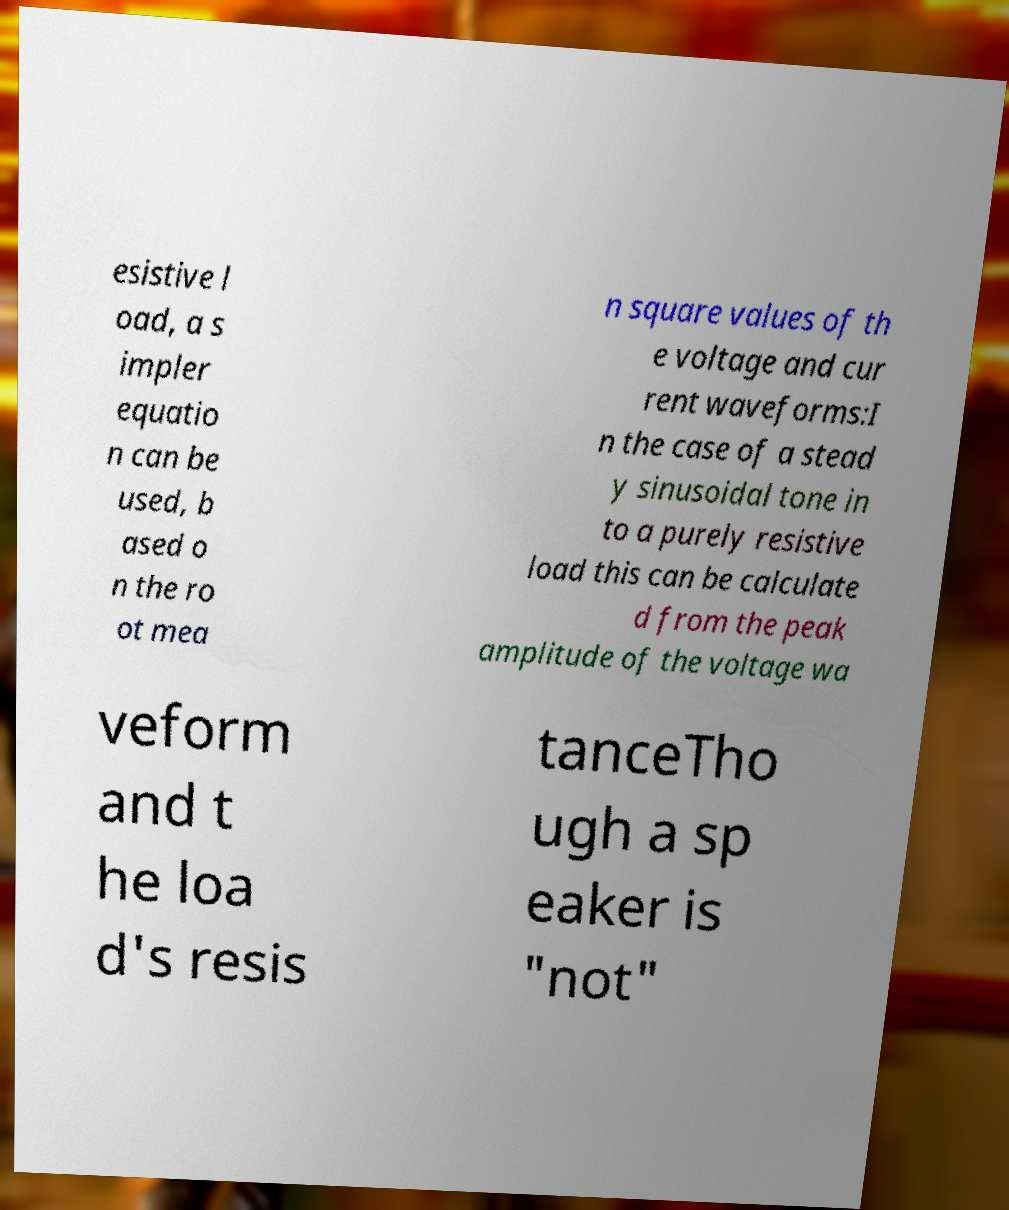For documentation purposes, I need the text within this image transcribed. Could you provide that? esistive l oad, a s impler equatio n can be used, b ased o n the ro ot mea n square values of th e voltage and cur rent waveforms:I n the case of a stead y sinusoidal tone in to a purely resistive load this can be calculate d from the peak amplitude of the voltage wa veform and t he loa d's resis tanceTho ugh a sp eaker is "not" 